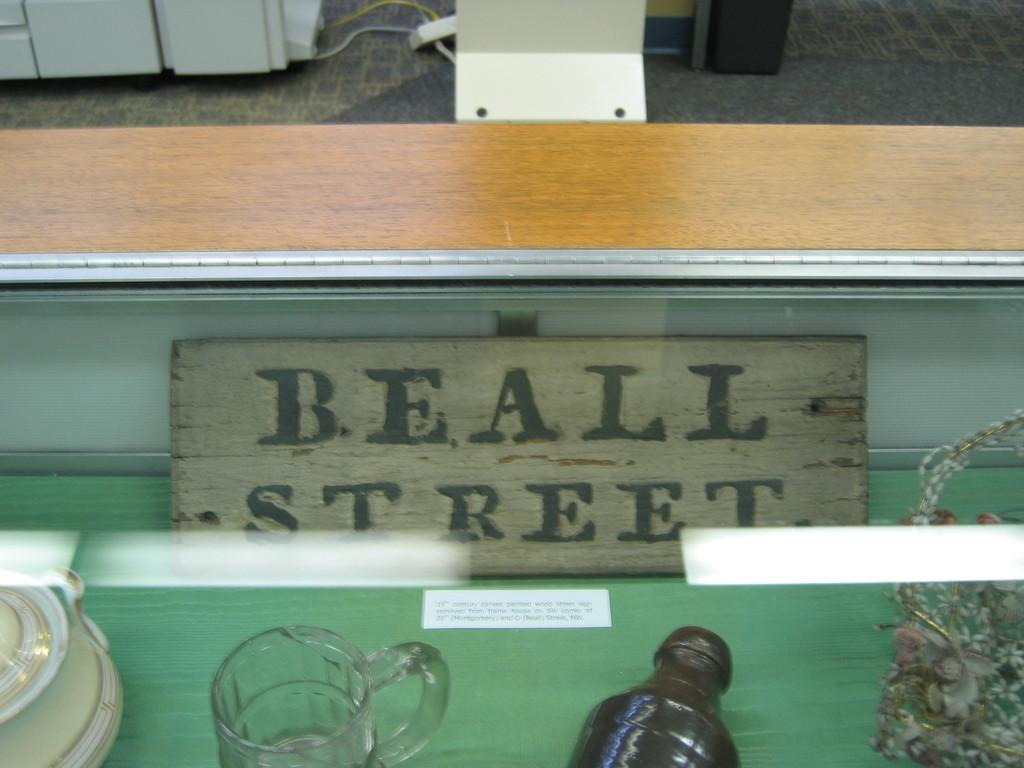<image>
Render a clear and concise summary of the photo. Collectibles and a sign that says Beall Street are displayed on a glass case. 